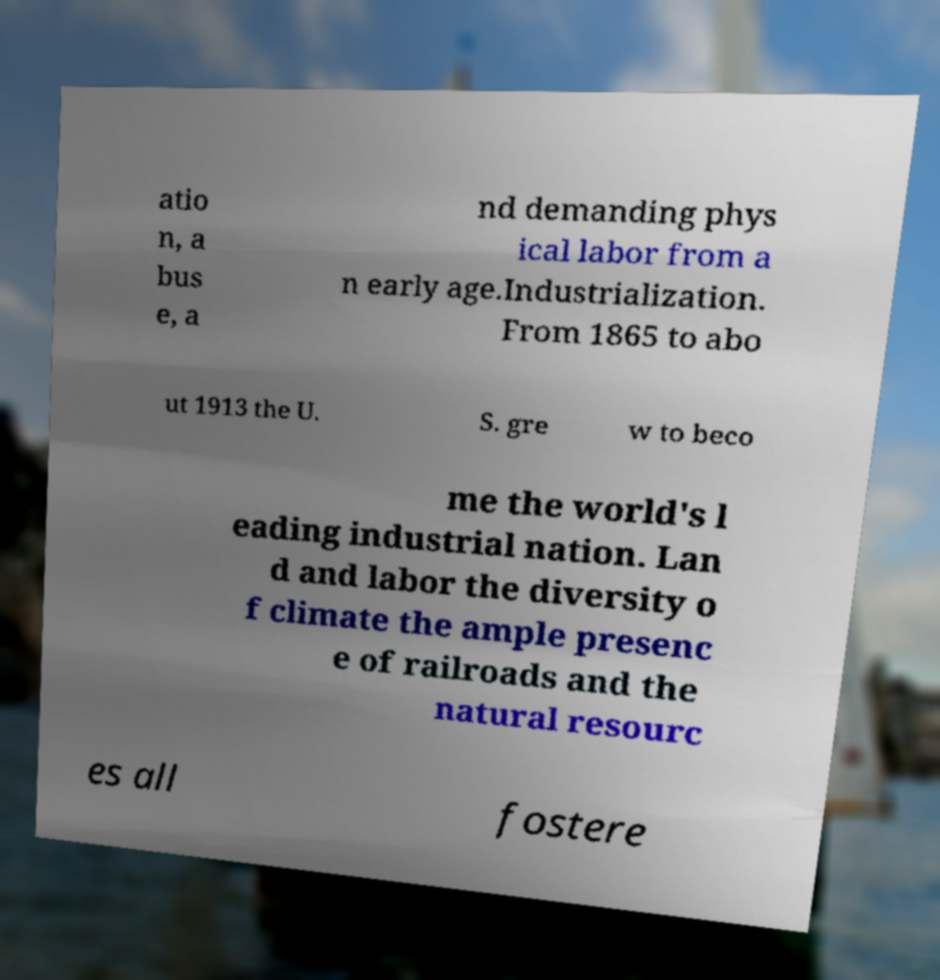Please read and relay the text visible in this image. What does it say? atio n, a bus e, a nd demanding phys ical labor from a n early age.Industrialization. From 1865 to abo ut 1913 the U. S. gre w to beco me the world's l eading industrial nation. Lan d and labor the diversity o f climate the ample presenc e of railroads and the natural resourc es all fostere 